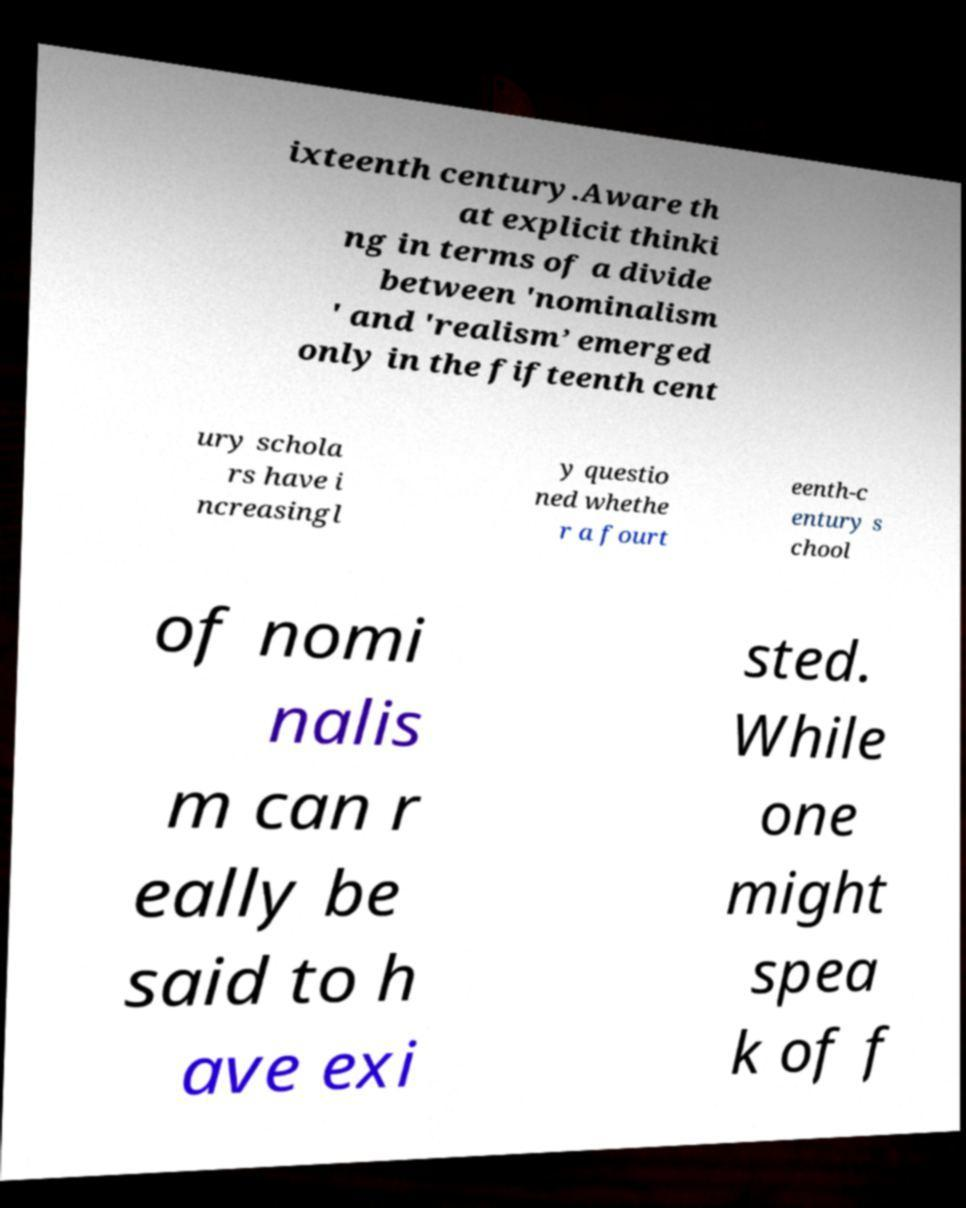Could you assist in decoding the text presented in this image and type it out clearly? ixteenth century.Aware th at explicit thinki ng in terms of a divide between 'nominalism ' and 'realism’ emerged only in the fifteenth cent ury schola rs have i ncreasingl y questio ned whethe r a fourt eenth-c entury s chool of nomi nalis m can r eally be said to h ave exi sted. While one might spea k of f 